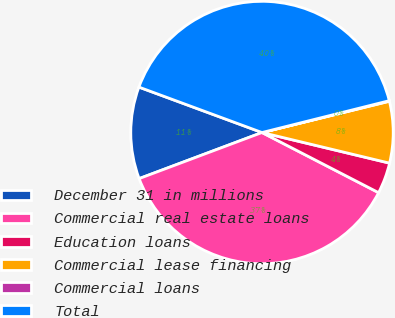Convert chart. <chart><loc_0><loc_0><loc_500><loc_500><pie_chart><fcel>December 31 in millions<fcel>Commercial real estate loans<fcel>Education loans<fcel>Commercial lease financing<fcel>Commercial loans<fcel>Total<nl><fcel>11.34%<fcel>36.71%<fcel>3.83%<fcel>7.58%<fcel>0.07%<fcel>40.47%<nl></chart> 